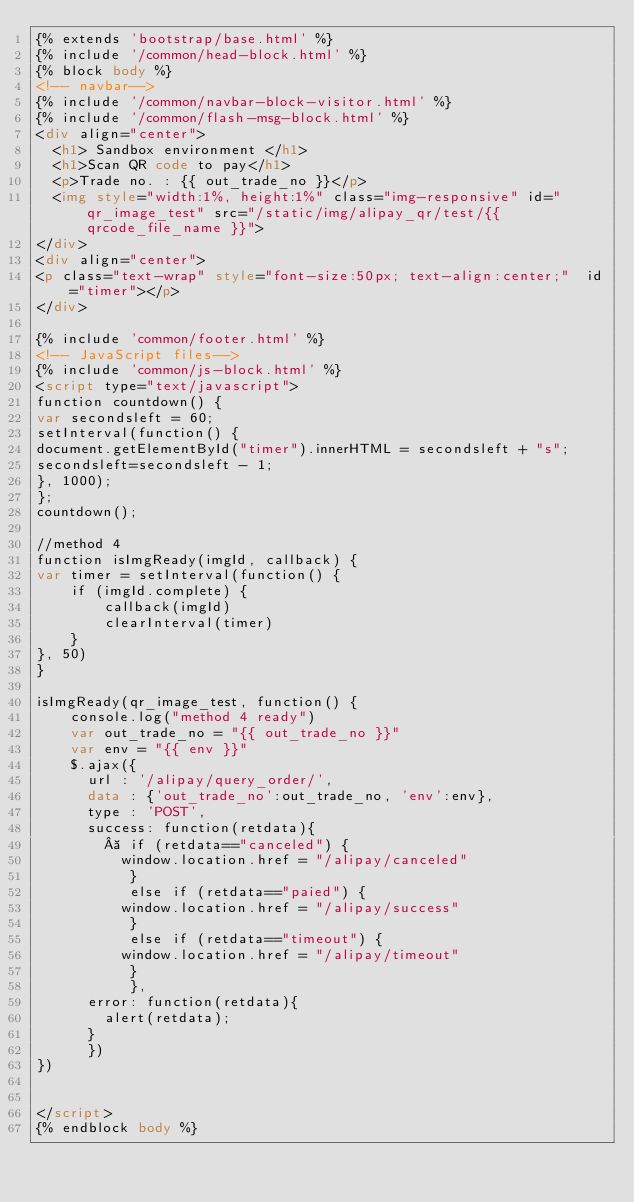<code> <loc_0><loc_0><loc_500><loc_500><_HTML_>{% extends 'bootstrap/base.html' %}
{% include '/common/head-block.html' %}
{% block body %}
<!-- navbar-->
{% include '/common/navbar-block-visitor.html' %}
{% include '/common/flash-msg-block.html' %}
<div align="center">
  <h1> Sandbox environment </h1>
  <h1>Scan QR code to pay</h1>
  <p>Trade no. : {{ out_trade_no }}</p>
  <img style="width:1%, height:1%" class="img-responsive" id="qr_image_test" src="/static/img/alipay_qr/test/{{ qrcode_file_name }}">
</div>
<div align="center">
<p class="text-wrap" style="font-size:50px; text-align:center;"  id="timer"></p>
</div>

{% include 'common/footer.html' %}
<!-- JavaScript files-->
{% include 'common/js-block.html' %}
<script type="text/javascript">
function countdown() {
var secondsleft = 60;
setInterval(function() {
document.getElementById("timer").innerHTML = secondsleft + "s";
secondsleft=secondsleft - 1;
}, 1000);
};
countdown();

//method 4
function isImgReady(imgId, callback) {
var timer = setInterval(function() {
    if (imgId.complete) {
        callback(imgId)
        clearInterval(timer)
    }
}, 50)
}

isImgReady(qr_image_test, function() {
    console.log("method 4 ready")
    var out_trade_no = "{{ out_trade_no }}"
    var env = "{{ env }}"
    $.ajax({
      url : '/alipay/query_order/',
      data : {'out_trade_no':out_trade_no, 'env':env},
      type : 'POST',
      success: function(retdata){
          if (retdata=="canceled") {
          window.location.href = "/alipay/canceled"
           }
           else if (retdata=="paied") {
          window.location.href = "/alipay/success"
           }
           else if (retdata=="timeout") {
          window.location.href = "/alipay/timeout"
           }
           },
      error: function(retdata){
        alert(retdata);
      }
      })
})


</script>
{% endblock body %}</code> 